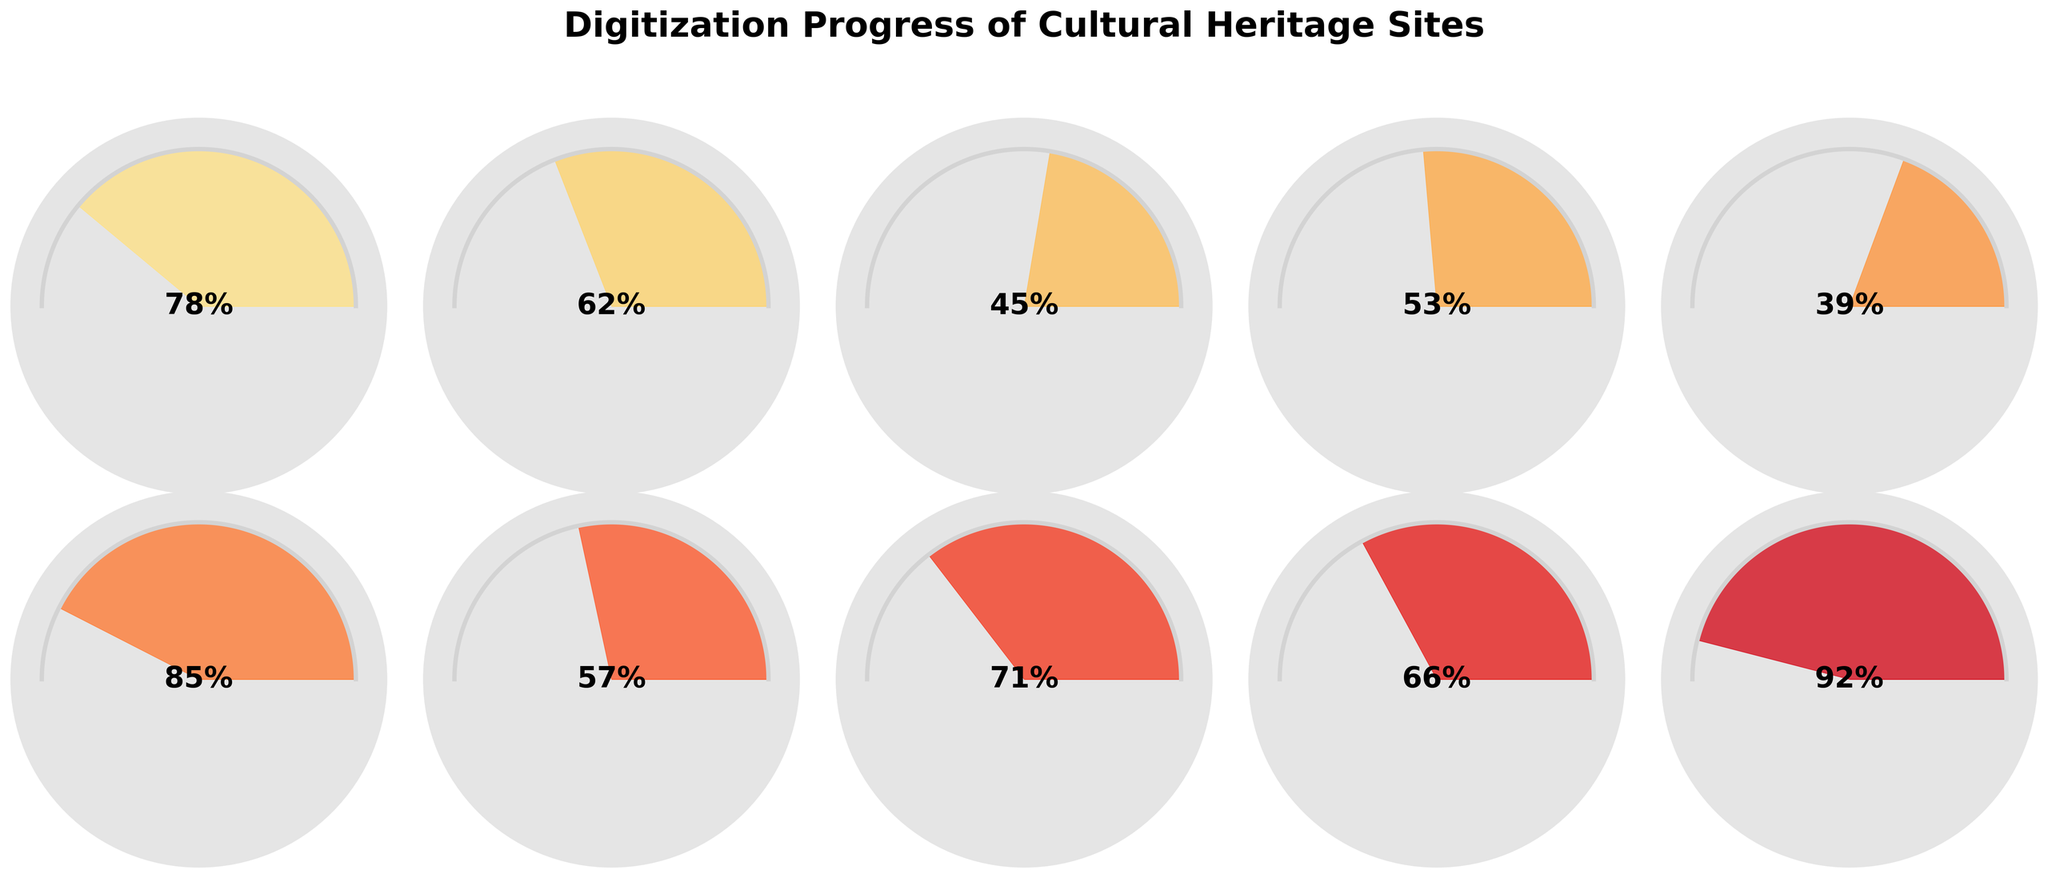Which cultural heritage site has the highest digitization progress according to the chart? The chart shows a gauge for each site's digitization percentage. The highest digitization progress is indicated at 92% for Pompeii.
Answer: Pompeii Which cultural heritage site has the lowest digitization progress according to the chart? The chart shows a gauge for each site's digitization percentage. The lowest digitization progress is indicated at 39% for the Great Wall of China.
Answer: Great Wall of China How many sites have a digitization progress of more than 70%? By checking each gauge, we find that Machu Picchu (78%), Stonehenge (85%), Taj Mahal (71%), and Pompeii (92%) have digitization progress above 70%. This makes a total of 4 sites.
Answer: 4 What is the average digitization percentage of the cultural heritage sites? Sum of the percentages: 78 + 62 + 45 + 53 + 39 + 85 + 57 + 71 + 66 + 92 = 648. There are 10 sites in total, so the average is 648 / 10 = 64.8%.
Answer: 64.8% Which site has a digitization progress closest to the average digitization percentage? The average digitization percentage is 64.8%. The closest site to this value is the Acropolis of Athens, with 62%.
Answer: Acropolis of Athens Compare the digitization progress of Machu Picchu and Stonehenge. Which one is more advanced and by how much? Machu Picchu has a digitization percentage of 78%, while Stonehenge is at 85%. Stonehenge is more advanced by 85% - 78% = 7%.
Answer: Stonehenge, 7% What is the total digitization percentage for all heritage sites combined? Summing up the digitization percentages of all the sites: 78 + 62 + 45 + 53 + 39 + 85 + 57 + 71 + 66 + 92 = 648.
Answer: 648% What is the median digitization percentage among all heritage sites? When the percentages are arranged in ascending order (39, 45, 53, 57, 62, 66, 71, 78, 85, 92), the median value, being the middle value of this ordered list, is (62 + 66) / 2 = 64%.
Answer: 64% What is the range of digitization percentages for the cultural heritage sites? The range is calculated by subtracting the smallest percentage from the largest. Thus, range = 92% - 39% = 53 percentage points.
Answer: 53 If a new heritage site is added with a digitization progress of 55%, how does this change the average digitization percentage? Including a new site with 55% digitization: New total = 648 + 55 = 703. New number of sites = 10 + 1 = 11. New average = 703 / 11 ≈ 63.91%.
Answer: 63.91% 